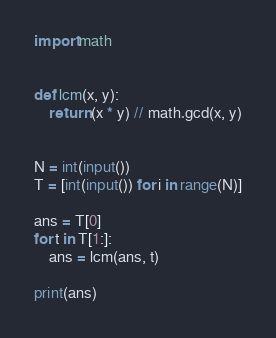<code> <loc_0><loc_0><loc_500><loc_500><_Python_>import math


def lcm(x, y):
    return (x * y) // math.gcd(x, y)


N = int(input())
T = [int(input()) for i in range(N)]

ans = T[0]
for t in T[1:]:
    ans = lcm(ans, t)

print(ans)</code> 